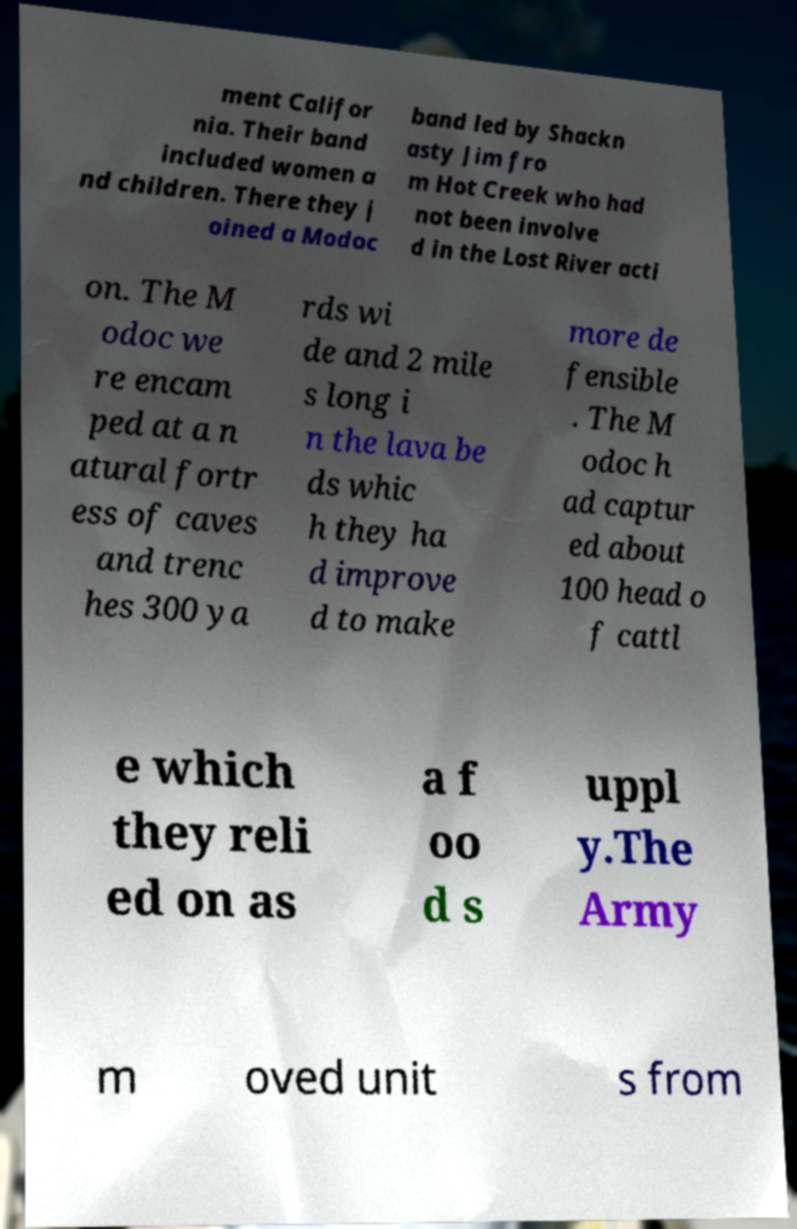Please identify and transcribe the text found in this image. ment Califor nia. Their band included women a nd children. There they j oined a Modoc band led by Shackn asty Jim fro m Hot Creek who had not been involve d in the Lost River acti on. The M odoc we re encam ped at a n atural fortr ess of caves and trenc hes 300 ya rds wi de and 2 mile s long i n the lava be ds whic h they ha d improve d to make more de fensible . The M odoc h ad captur ed about 100 head o f cattl e which they reli ed on as a f oo d s uppl y.The Army m oved unit s from 